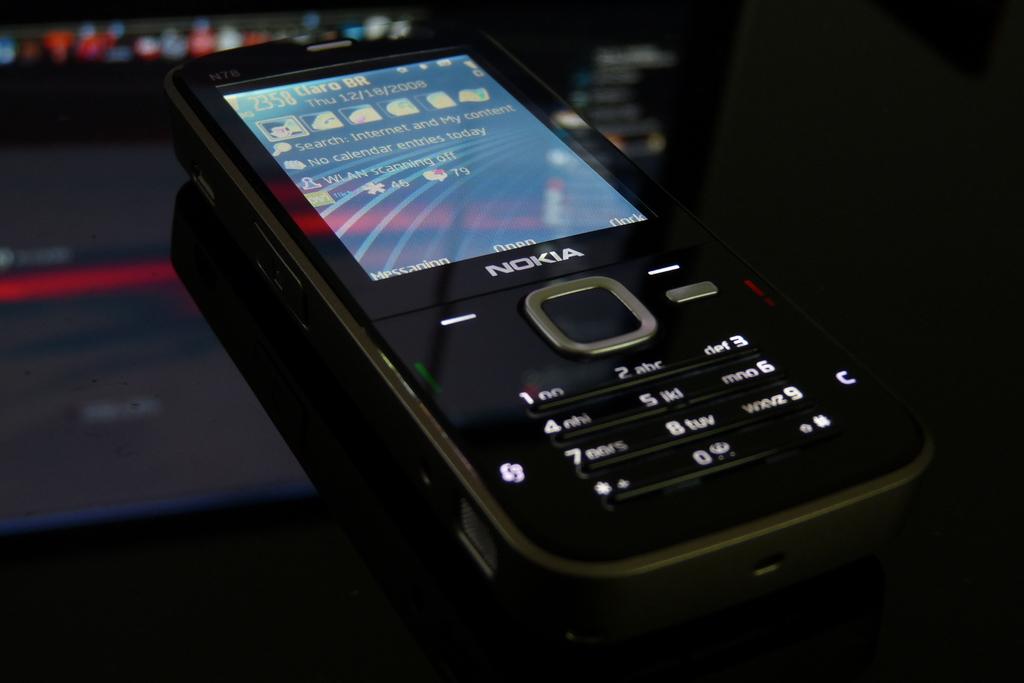What is the brand of the phone?
Make the answer very short. Nokia. What time is displayed on the phone?
Provide a succinct answer. 23:58. 